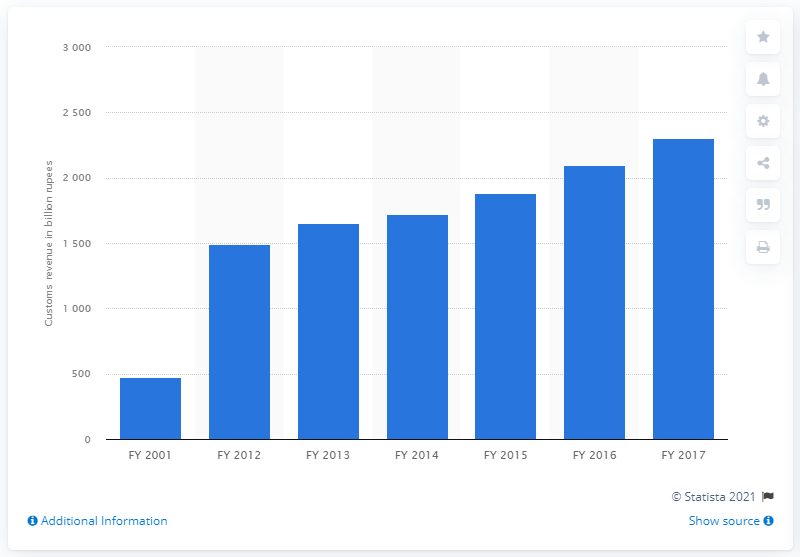Mention a couple of crucial points in this snapshot. In 2017, India's customs revenue was approximately 2,300. 